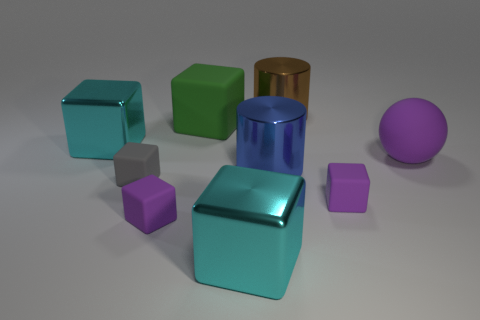There is a big cylinder behind the purple rubber sphere; is its color the same as the large ball?
Your answer should be compact. No. How many things are either blocks that are in front of the green rubber thing or purple rubber cubes?
Your response must be concise. 5. Are there any small purple cubes behind the purple rubber sphere?
Provide a succinct answer. No. Do the tiny gray cube on the left side of the sphere and the big purple ball have the same material?
Offer a very short reply. Yes. Is there a gray thing that is in front of the matte thing on the left side of the tiny purple matte cube on the left side of the large brown shiny thing?
Keep it short and to the point. No. What number of cubes are cyan objects or big brown metal objects?
Make the answer very short. 2. What is the cyan thing in front of the large blue object made of?
Provide a succinct answer. Metal. Is the color of the metal cube that is on the right side of the small gray rubber object the same as the object that is on the left side of the tiny gray rubber object?
Provide a short and direct response. Yes. What number of objects are either cyan objects or metal cylinders?
Provide a short and direct response. 4. What number of other objects are the same shape as the big brown metal object?
Your answer should be compact. 1. 